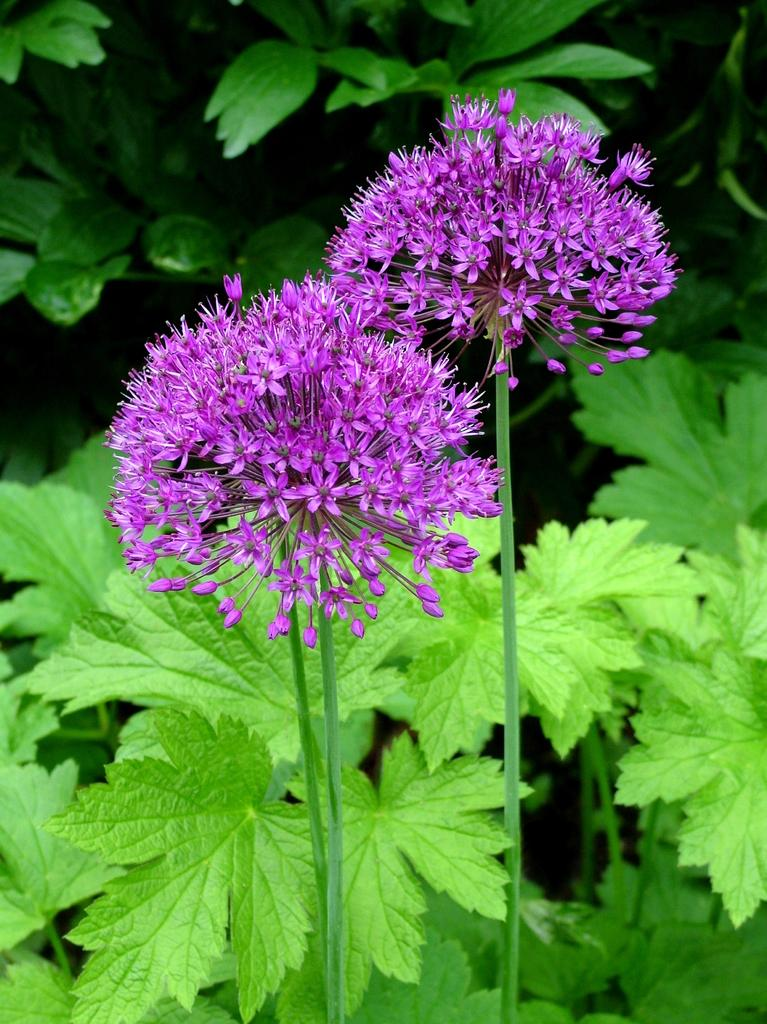What type of flowers can be seen in the image? There are purple color flowers in the image. What else can be seen in the background of the image? There are leaves in the background of the image. What type of advertisement is displayed on the flowers in the image? There is no advertisement present on the flowers in the image; it is a simple image of flowers and leaves. 